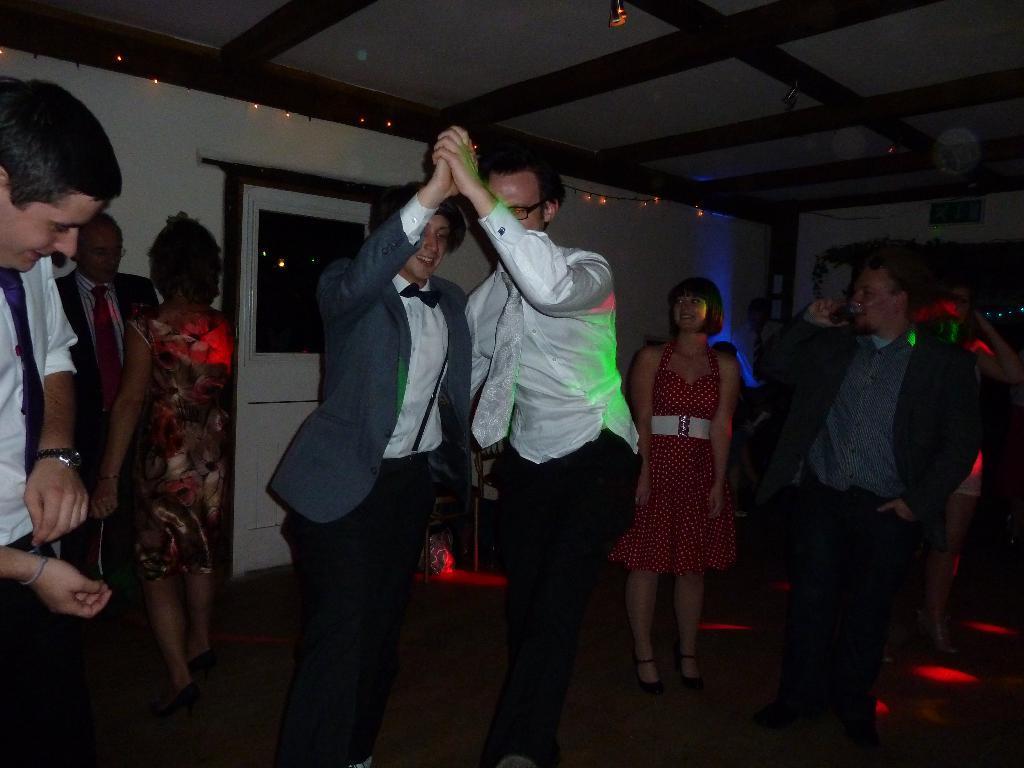Could you give a brief overview of what you see in this image? This picture is clicked inside. In the center we can see the two persons seems to be dancing. On the left we can see the group of persons. On the right there is a man wearing suit, standing on the ground and drinking. In the background there is a wall and we can see the decoration lights and we can see the door, roof, lights and many other objects. 